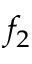<formula> <loc_0><loc_0><loc_500><loc_500>f _ { 2 }</formula> 